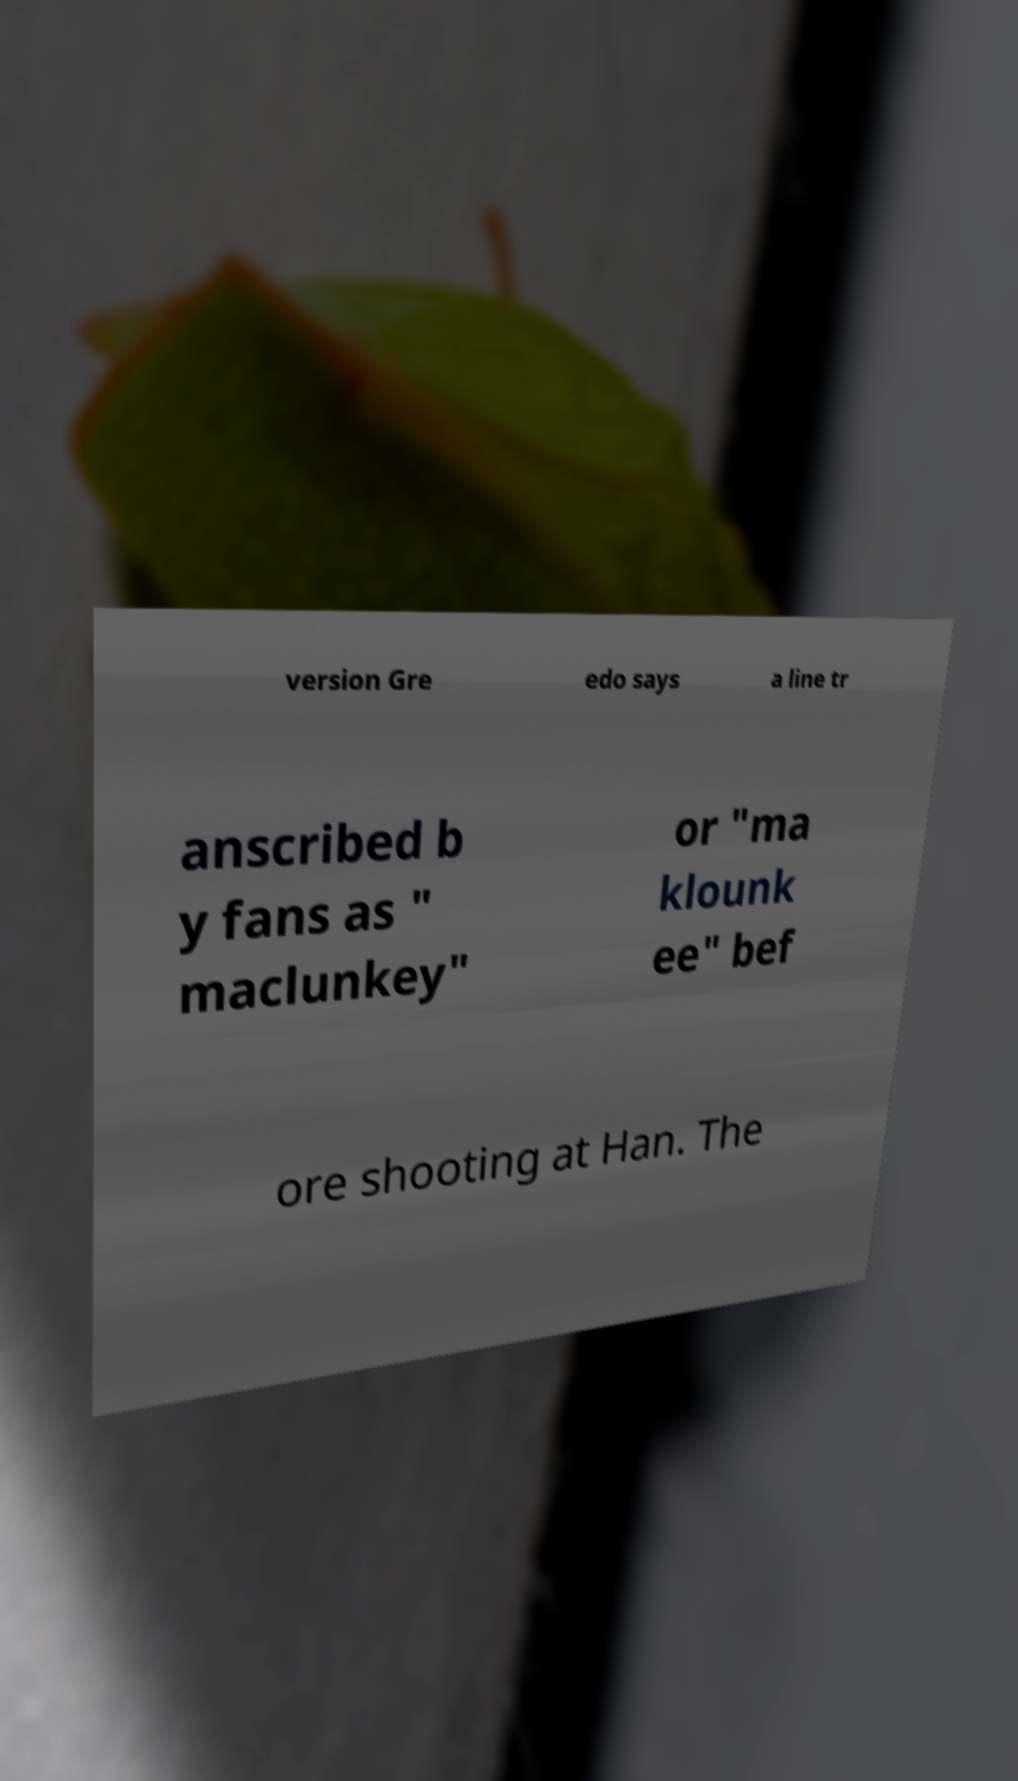Please identify and transcribe the text found in this image. version Gre edo says a line tr anscribed b y fans as " maclunkey" or "ma klounk ee" bef ore shooting at Han. The 